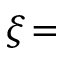Convert formula to latex. <formula><loc_0><loc_0><loc_500><loc_500>\xi \, =</formula> 